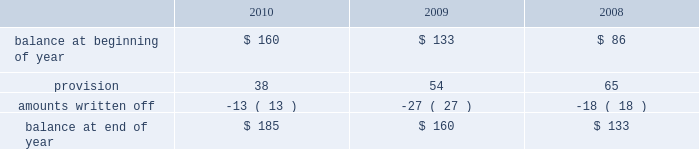Allowance for doubtful accounts is as follows: .
Discontinued operations during the fourth quarter of 2009 , schlumberger recorded a net $ 22 million charge related to the resolution of a customs assessment pertaining to its former offshore contract drilling business , as well as the resolution of certain contingencies associated with other previously disposed of businesses .
This amount is included in income ( loss ) from discontinued operations in the consolidated statement of income .
During the first quarter of 2008 , schlumberger recorded a gain of $ 38 million related to the resolution of a contingency associated with a previously disposed of business .
This gain is included in income ( loss ) from discon- tinued operations in the consolidated statement of income .
Part ii , item 8 .
In 2010 , what was the provision for doubtful accounts as a percentage of total allowance for doubtful accounts? 
Computations: (38 / 160)
Answer: 0.2375. 